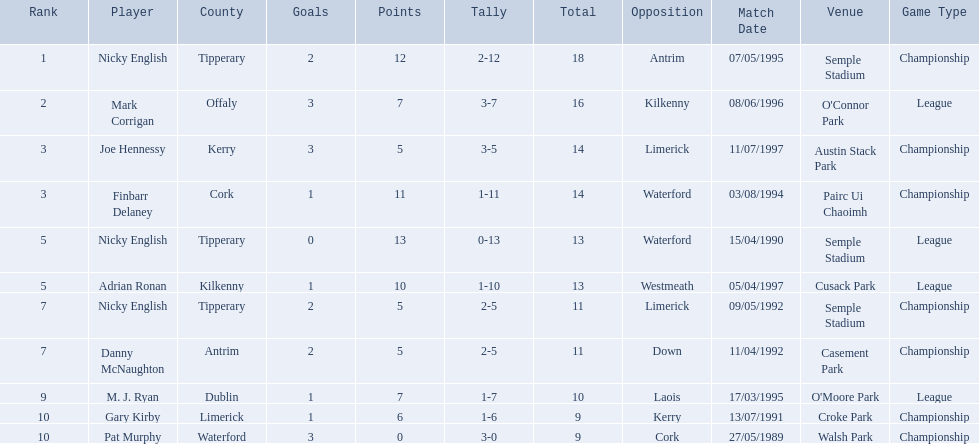What numbers are in the total column? 18, 16, 14, 14, 13, 13, 11, 11, 10, 9, 9. What row has the number 10 in the total column? 9, M. J. Ryan, Dublin, 1-7, 10, Laois. What name is in the player column for this row? M. J. Ryan. 